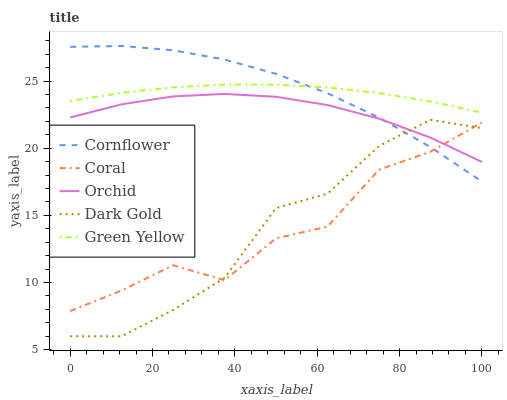Does Coral have the minimum area under the curve?
Answer yes or no. Yes. Does Cornflower have the maximum area under the curve?
Answer yes or no. Yes. Does Dark Gold have the minimum area under the curve?
Answer yes or no. No. Does Dark Gold have the maximum area under the curve?
Answer yes or no. No. Is Green Yellow the smoothest?
Answer yes or no. Yes. Is Coral the roughest?
Answer yes or no. Yes. Is Dark Gold the smoothest?
Answer yes or no. No. Is Dark Gold the roughest?
Answer yes or no. No. Does Dark Gold have the lowest value?
Answer yes or no. Yes. Does Coral have the lowest value?
Answer yes or no. No. Does Cornflower have the highest value?
Answer yes or no. Yes. Does Dark Gold have the highest value?
Answer yes or no. No. Is Dark Gold less than Green Yellow?
Answer yes or no. Yes. Is Green Yellow greater than Dark Gold?
Answer yes or no. Yes. Does Coral intersect Orchid?
Answer yes or no. Yes. Is Coral less than Orchid?
Answer yes or no. No. Is Coral greater than Orchid?
Answer yes or no. No. Does Dark Gold intersect Green Yellow?
Answer yes or no. No. 